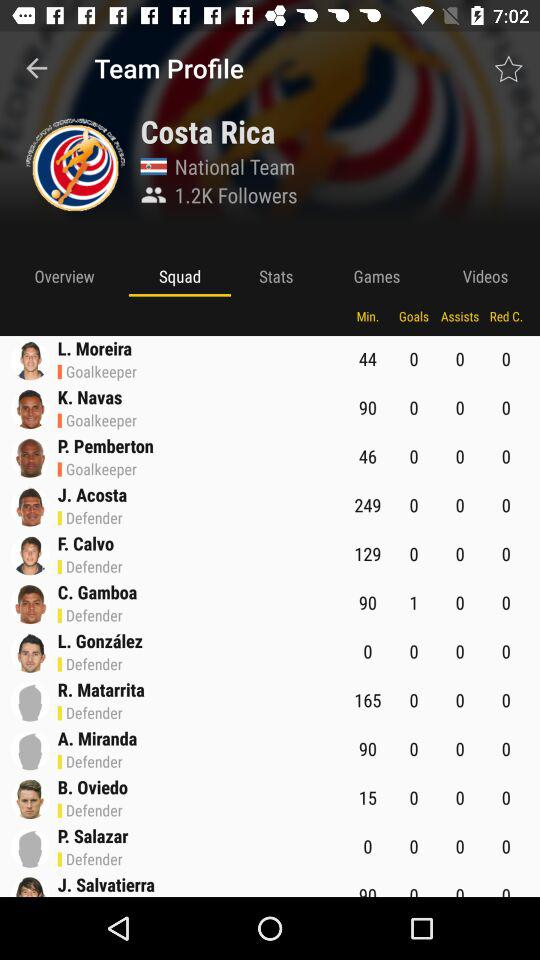What is the selected tab? The selected tab is "Squad". 